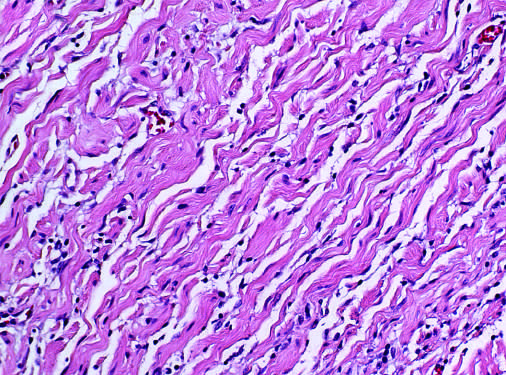s the electron micrograph of gaucher cells with likened to carrot shavings?
Answer the question using a single word or phrase. No 